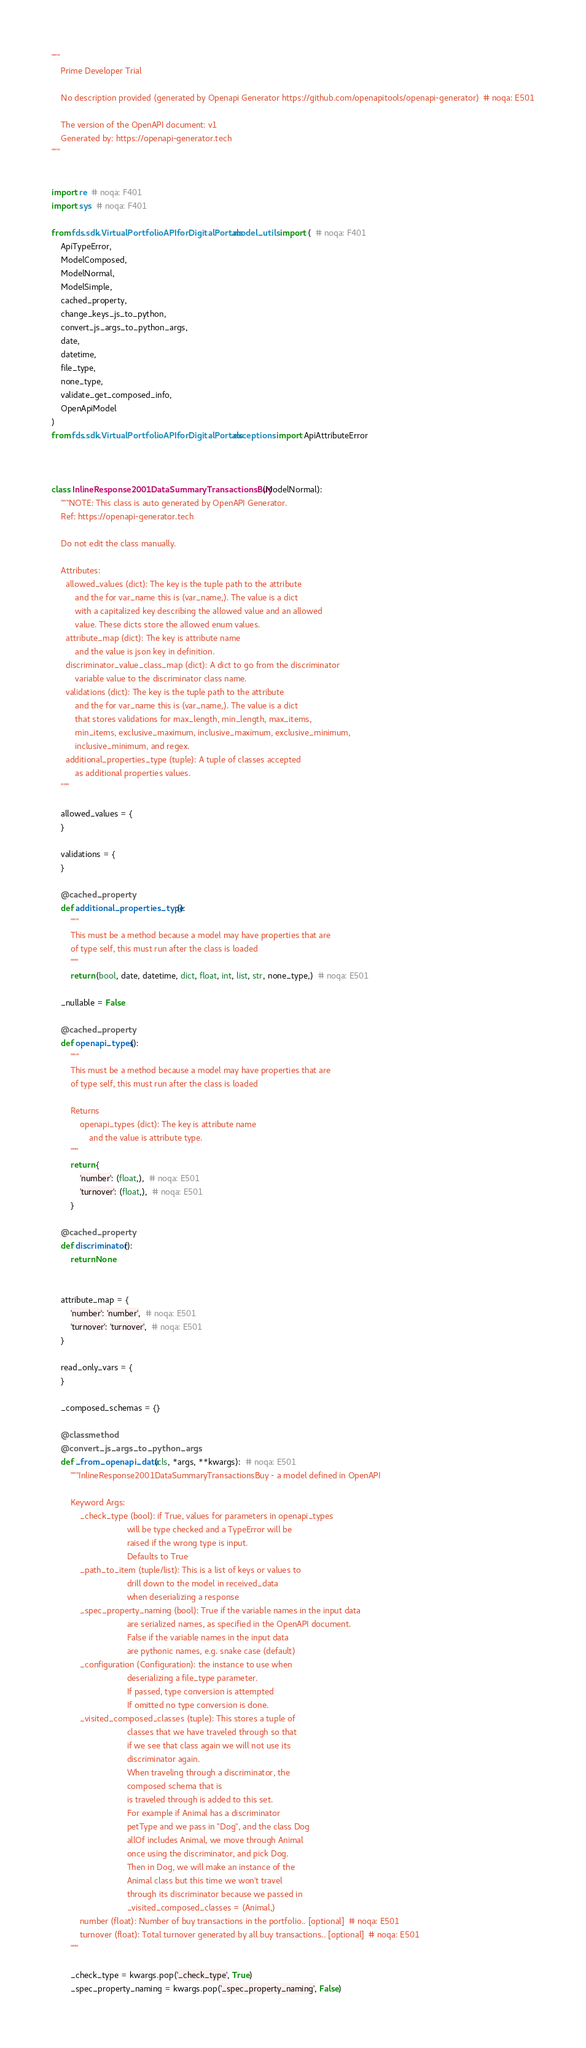Convert code to text. <code><loc_0><loc_0><loc_500><loc_500><_Python_>"""
    Prime Developer Trial

    No description provided (generated by Openapi Generator https://github.com/openapitools/openapi-generator)  # noqa: E501

    The version of the OpenAPI document: v1
    Generated by: https://openapi-generator.tech
"""


import re  # noqa: F401
import sys  # noqa: F401

from fds.sdk.VirtualPortfolioAPIforDigitalPortals.model_utils import (  # noqa: F401
    ApiTypeError,
    ModelComposed,
    ModelNormal,
    ModelSimple,
    cached_property,
    change_keys_js_to_python,
    convert_js_args_to_python_args,
    date,
    datetime,
    file_type,
    none_type,
    validate_get_composed_info,
    OpenApiModel
)
from fds.sdk.VirtualPortfolioAPIforDigitalPortals.exceptions import ApiAttributeError



class InlineResponse2001DataSummaryTransactionsBuy(ModelNormal):
    """NOTE: This class is auto generated by OpenAPI Generator.
    Ref: https://openapi-generator.tech

    Do not edit the class manually.

    Attributes:
      allowed_values (dict): The key is the tuple path to the attribute
          and the for var_name this is (var_name,). The value is a dict
          with a capitalized key describing the allowed value and an allowed
          value. These dicts store the allowed enum values.
      attribute_map (dict): The key is attribute name
          and the value is json key in definition.
      discriminator_value_class_map (dict): A dict to go from the discriminator
          variable value to the discriminator class name.
      validations (dict): The key is the tuple path to the attribute
          and the for var_name this is (var_name,). The value is a dict
          that stores validations for max_length, min_length, max_items,
          min_items, exclusive_maximum, inclusive_maximum, exclusive_minimum,
          inclusive_minimum, and regex.
      additional_properties_type (tuple): A tuple of classes accepted
          as additional properties values.
    """

    allowed_values = {
    }

    validations = {
    }

    @cached_property
    def additional_properties_type():
        """
        This must be a method because a model may have properties that are
        of type self, this must run after the class is loaded
        """
        return (bool, date, datetime, dict, float, int, list, str, none_type,)  # noqa: E501

    _nullable = False

    @cached_property
    def openapi_types():
        """
        This must be a method because a model may have properties that are
        of type self, this must run after the class is loaded

        Returns
            openapi_types (dict): The key is attribute name
                and the value is attribute type.
        """
        return {
            'number': (float,),  # noqa: E501
            'turnover': (float,),  # noqa: E501
        }

    @cached_property
    def discriminator():
        return None


    attribute_map = {
        'number': 'number',  # noqa: E501
        'turnover': 'turnover',  # noqa: E501
    }

    read_only_vars = {
    }

    _composed_schemas = {}

    @classmethod
    @convert_js_args_to_python_args
    def _from_openapi_data(cls, *args, **kwargs):  # noqa: E501
        """InlineResponse2001DataSummaryTransactionsBuy - a model defined in OpenAPI

        Keyword Args:
            _check_type (bool): if True, values for parameters in openapi_types
                                will be type checked and a TypeError will be
                                raised if the wrong type is input.
                                Defaults to True
            _path_to_item (tuple/list): This is a list of keys or values to
                                drill down to the model in received_data
                                when deserializing a response
            _spec_property_naming (bool): True if the variable names in the input data
                                are serialized names, as specified in the OpenAPI document.
                                False if the variable names in the input data
                                are pythonic names, e.g. snake case (default)
            _configuration (Configuration): the instance to use when
                                deserializing a file_type parameter.
                                If passed, type conversion is attempted
                                If omitted no type conversion is done.
            _visited_composed_classes (tuple): This stores a tuple of
                                classes that we have traveled through so that
                                if we see that class again we will not use its
                                discriminator again.
                                When traveling through a discriminator, the
                                composed schema that is
                                is traveled through is added to this set.
                                For example if Animal has a discriminator
                                petType and we pass in "Dog", and the class Dog
                                allOf includes Animal, we move through Animal
                                once using the discriminator, and pick Dog.
                                Then in Dog, we will make an instance of the
                                Animal class but this time we won't travel
                                through its discriminator because we passed in
                                _visited_composed_classes = (Animal,)
            number (float): Number of buy transactions in the portfolio.. [optional]  # noqa: E501
            turnover (float): Total turnover generated by all buy transactions.. [optional]  # noqa: E501
        """

        _check_type = kwargs.pop('_check_type', True)
        _spec_property_naming = kwargs.pop('_spec_property_naming', False)</code> 